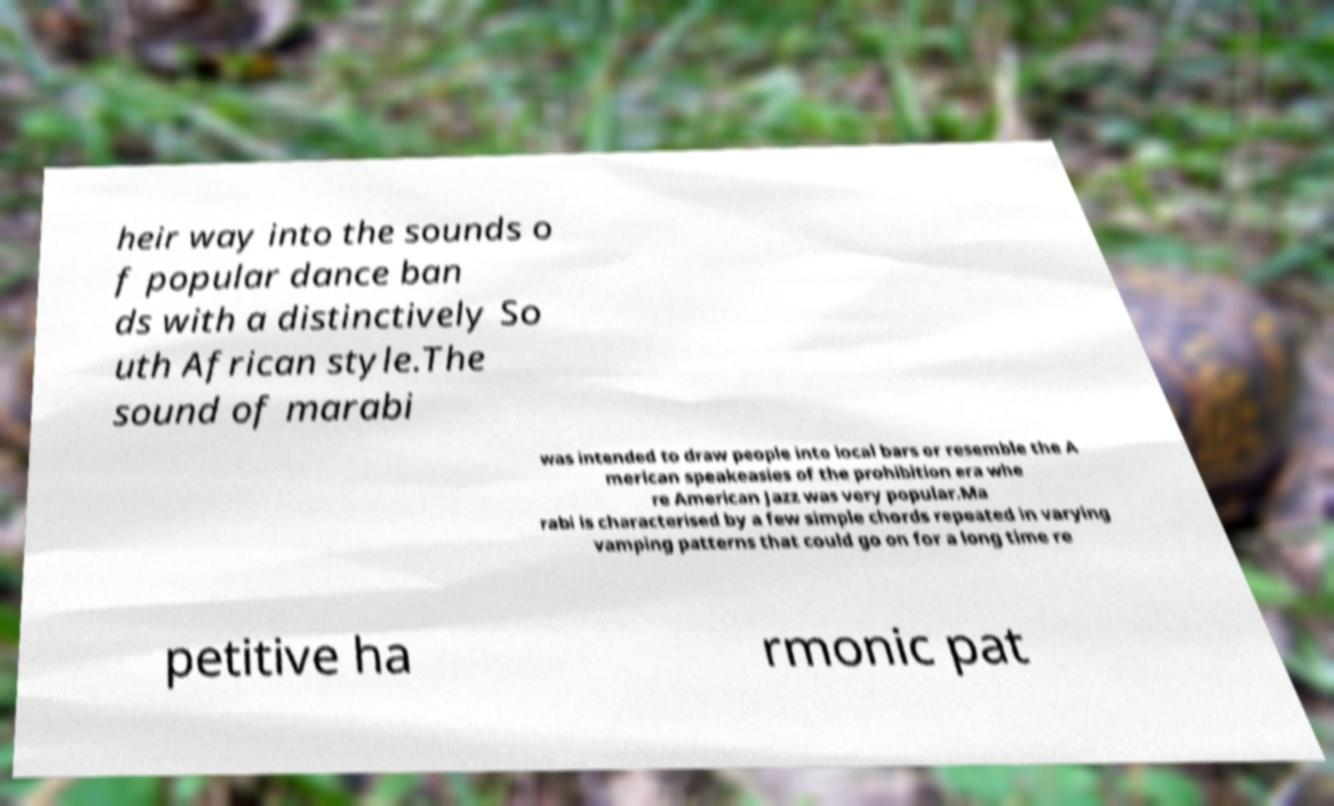Could you assist in decoding the text presented in this image and type it out clearly? heir way into the sounds o f popular dance ban ds with a distinctively So uth African style.The sound of marabi was intended to draw people into local bars or resemble the A merican speakeasies of the prohibition era whe re American Jazz was very popular.Ma rabi is characterised by a few simple chords repeated in varying vamping patterns that could go on for a long time re petitive ha rmonic pat 